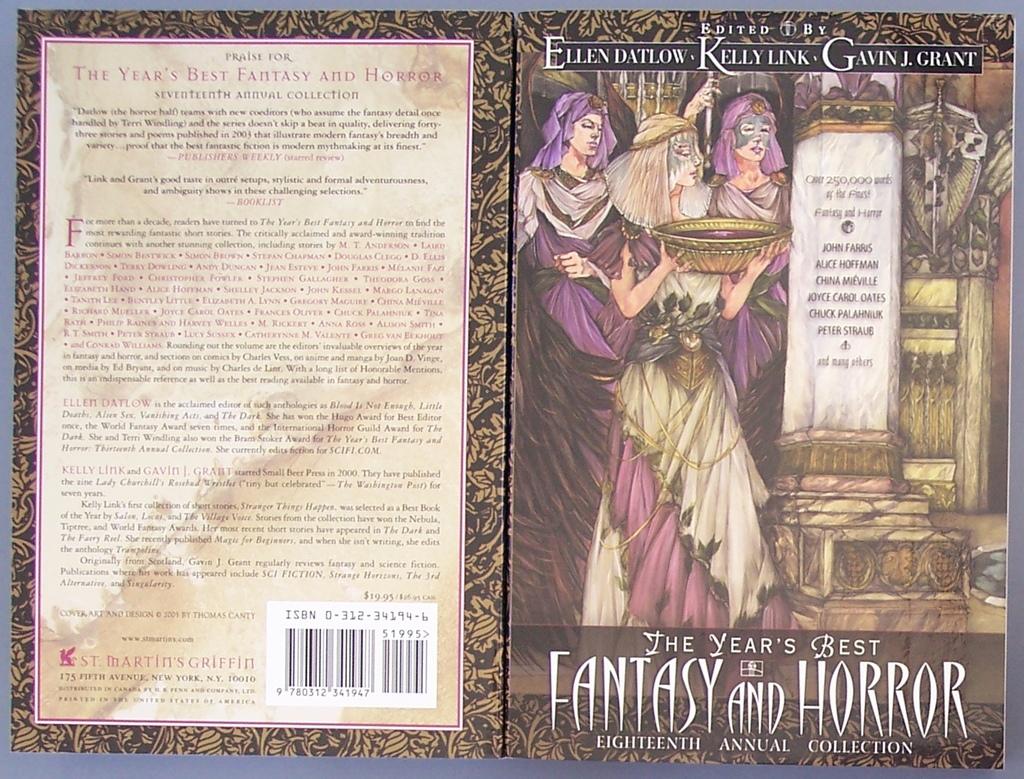What is the name of this book?
Your answer should be compact. The year's best fantasy and horror. 